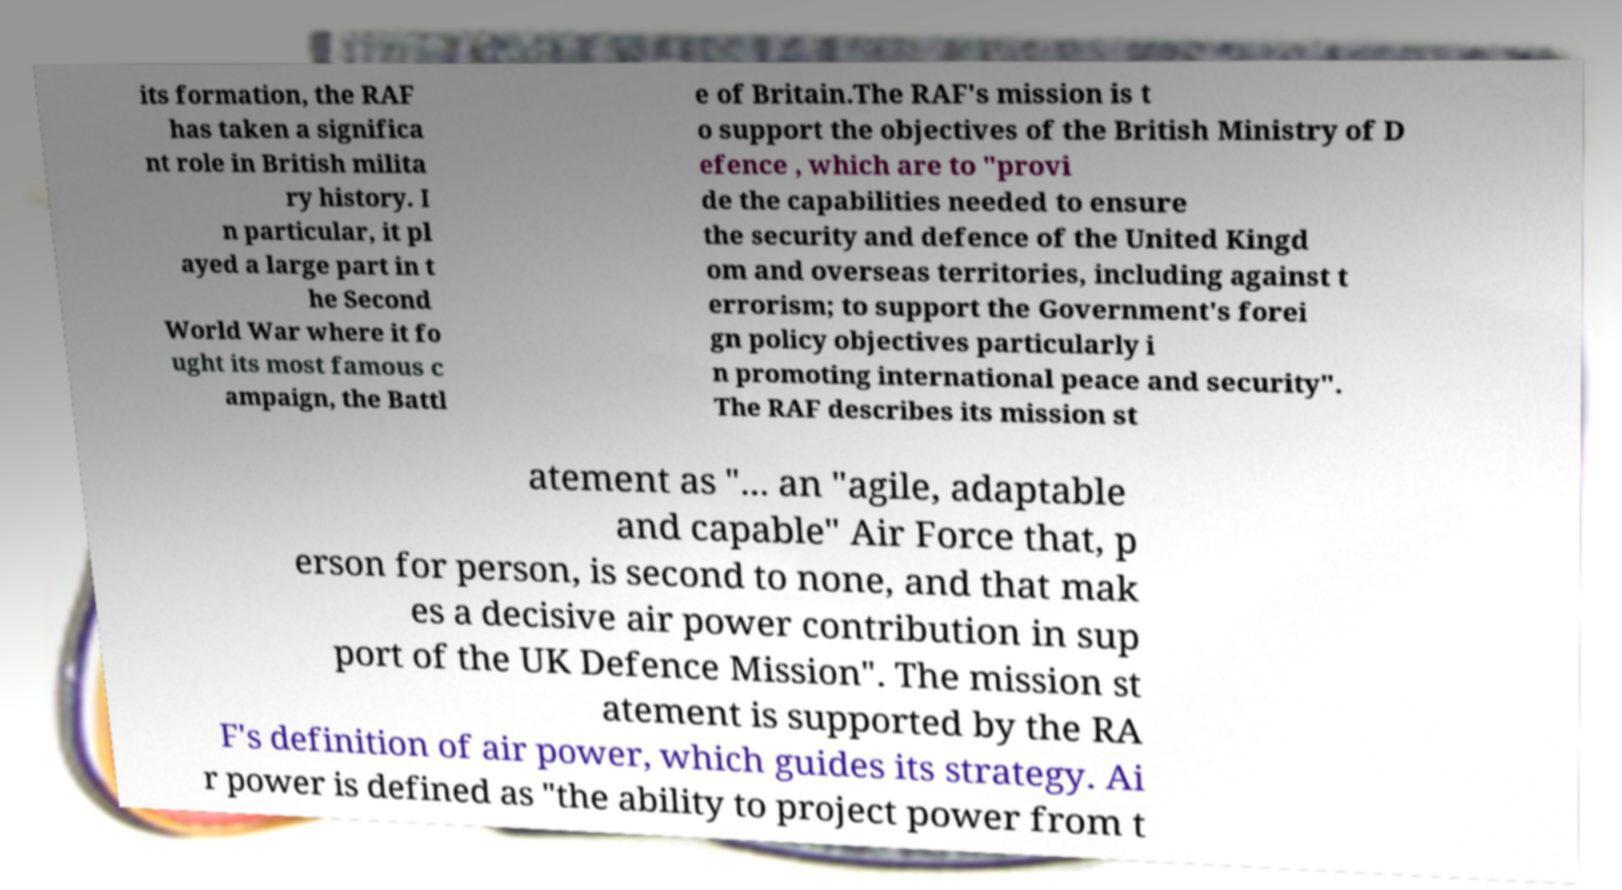I need the written content from this picture converted into text. Can you do that? its formation, the RAF has taken a significa nt role in British milita ry history. I n particular, it pl ayed a large part in t he Second World War where it fo ught its most famous c ampaign, the Battl e of Britain.The RAF's mission is t o support the objectives of the British Ministry of D efence , which are to "provi de the capabilities needed to ensure the security and defence of the United Kingd om and overseas territories, including against t errorism; to support the Government's forei gn policy objectives particularly i n promoting international peace and security". The RAF describes its mission st atement as "... an "agile, adaptable and capable" Air Force that, p erson for person, is second to none, and that mak es a decisive air power contribution in sup port of the UK Defence Mission". The mission st atement is supported by the RA F's definition of air power, which guides its strategy. Ai r power is defined as "the ability to project power from t 